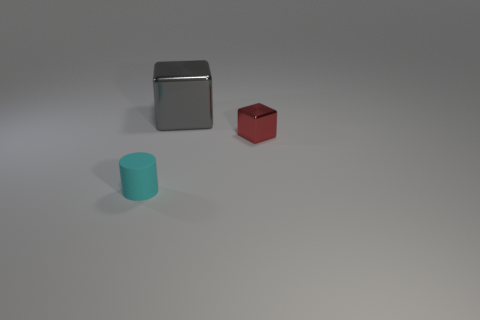Add 3 small matte balls. How many objects exist? 6 Subtract all cubes. How many objects are left? 1 Add 3 blue metallic things. How many blue metallic things exist? 3 Subtract 0 yellow balls. How many objects are left? 3 Subtract all red shiny cubes. Subtract all tiny red blocks. How many objects are left? 1 Add 3 tiny matte things. How many tiny matte things are left? 4 